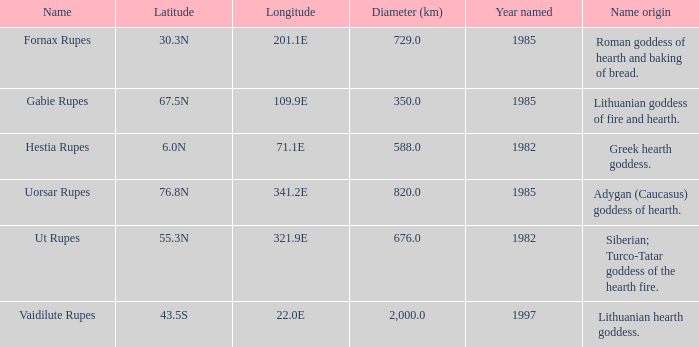At a latitude of 67.5n, what is the diameter? 350.0. 